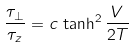Convert formula to latex. <formula><loc_0><loc_0><loc_500><loc_500>\frac { \tau _ { \perp } } { \tau _ { z } } = c \, \tanh ^ { 2 } \frac { V } { 2 T }</formula> 